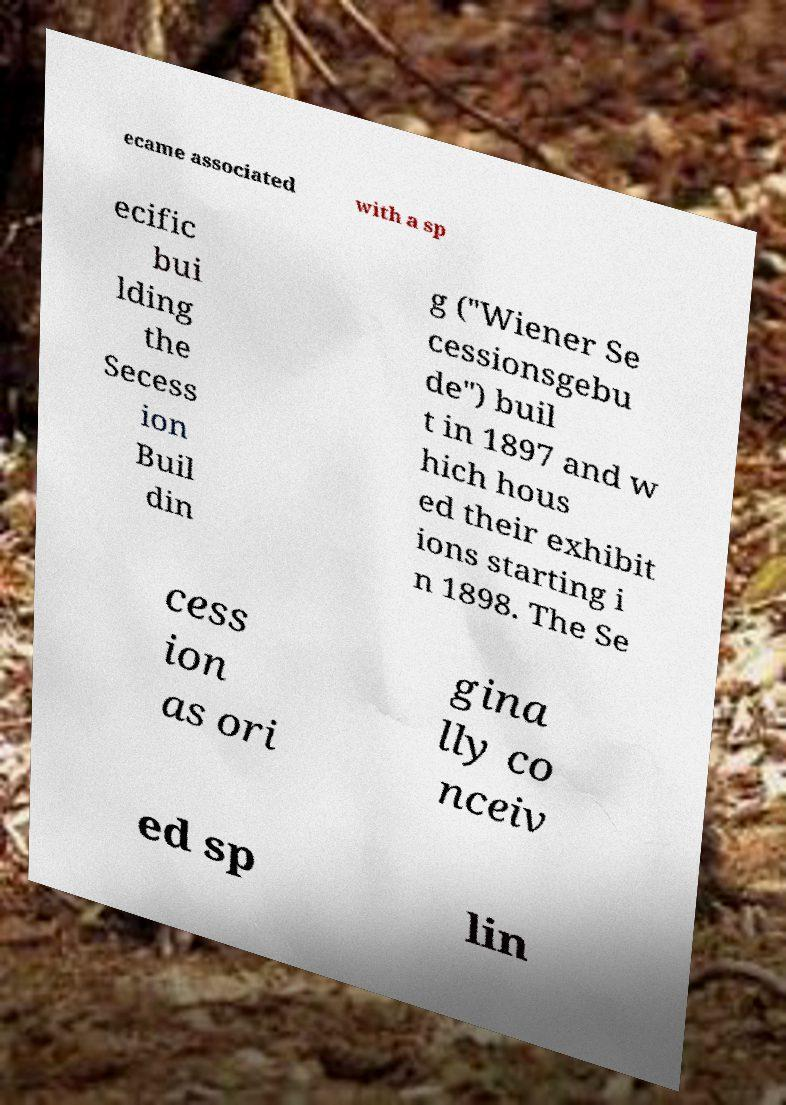Could you extract and type out the text from this image? ecame associated with a sp ecific bui lding the Secess ion Buil din g ("Wiener Se cessionsgebu de") buil t in 1897 and w hich hous ed their exhibit ions starting i n 1898. The Se cess ion as ori gina lly co nceiv ed sp lin 